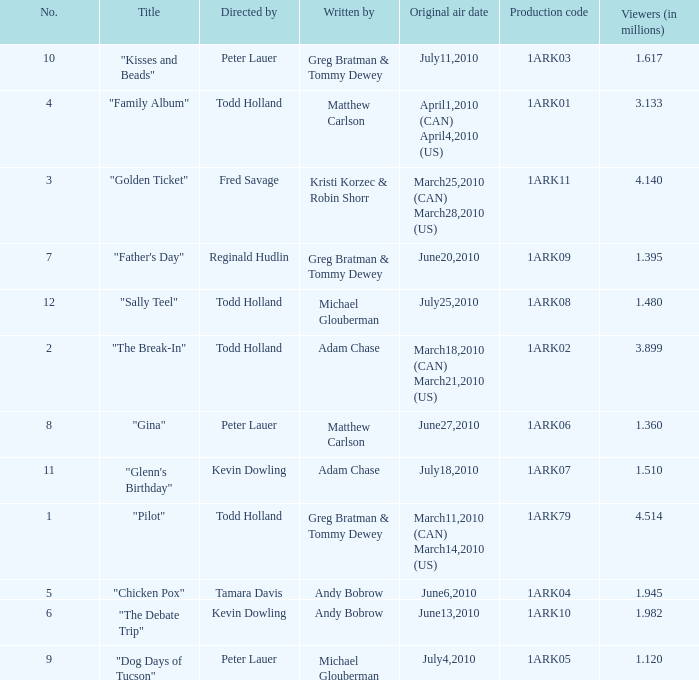How many millions of people viewed "Father's Day"? 1.395. 